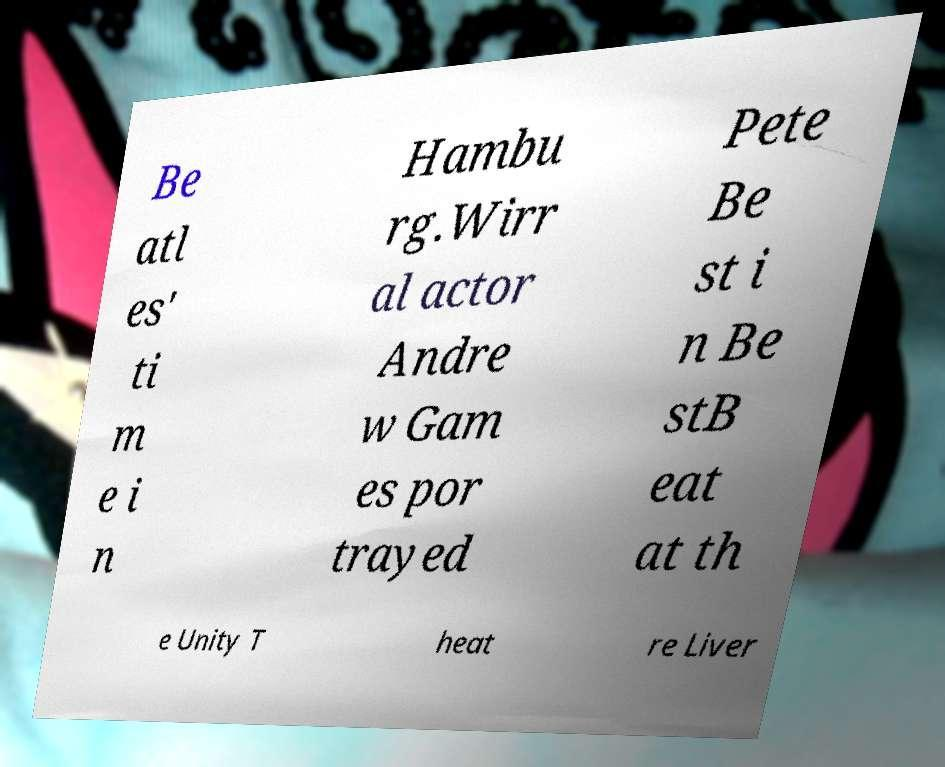Could you extract and type out the text from this image? Be atl es' ti m e i n Hambu rg.Wirr al actor Andre w Gam es por trayed Pete Be st i n Be stB eat at th e Unity T heat re Liver 